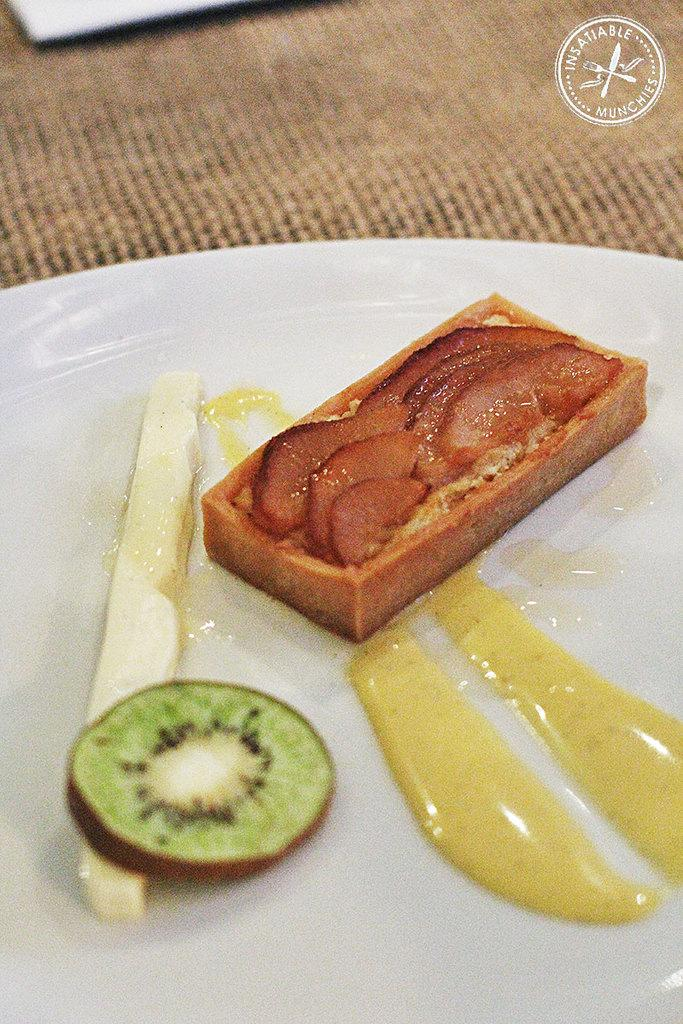What is on the plate in the image? There are food items on a white color plate in the image. Can you describe any additional features of the image? There is a watermark on the top right of the image. What can be seen in the background of the image? There is an object in the background of the image. How is the object in the background positioned? The object is on a cloth. What type of glove is being used to read the book in the image? There is no glove or book present in the image; it only features food items on a plate, a watermark, and an object in the background on a cloth. 